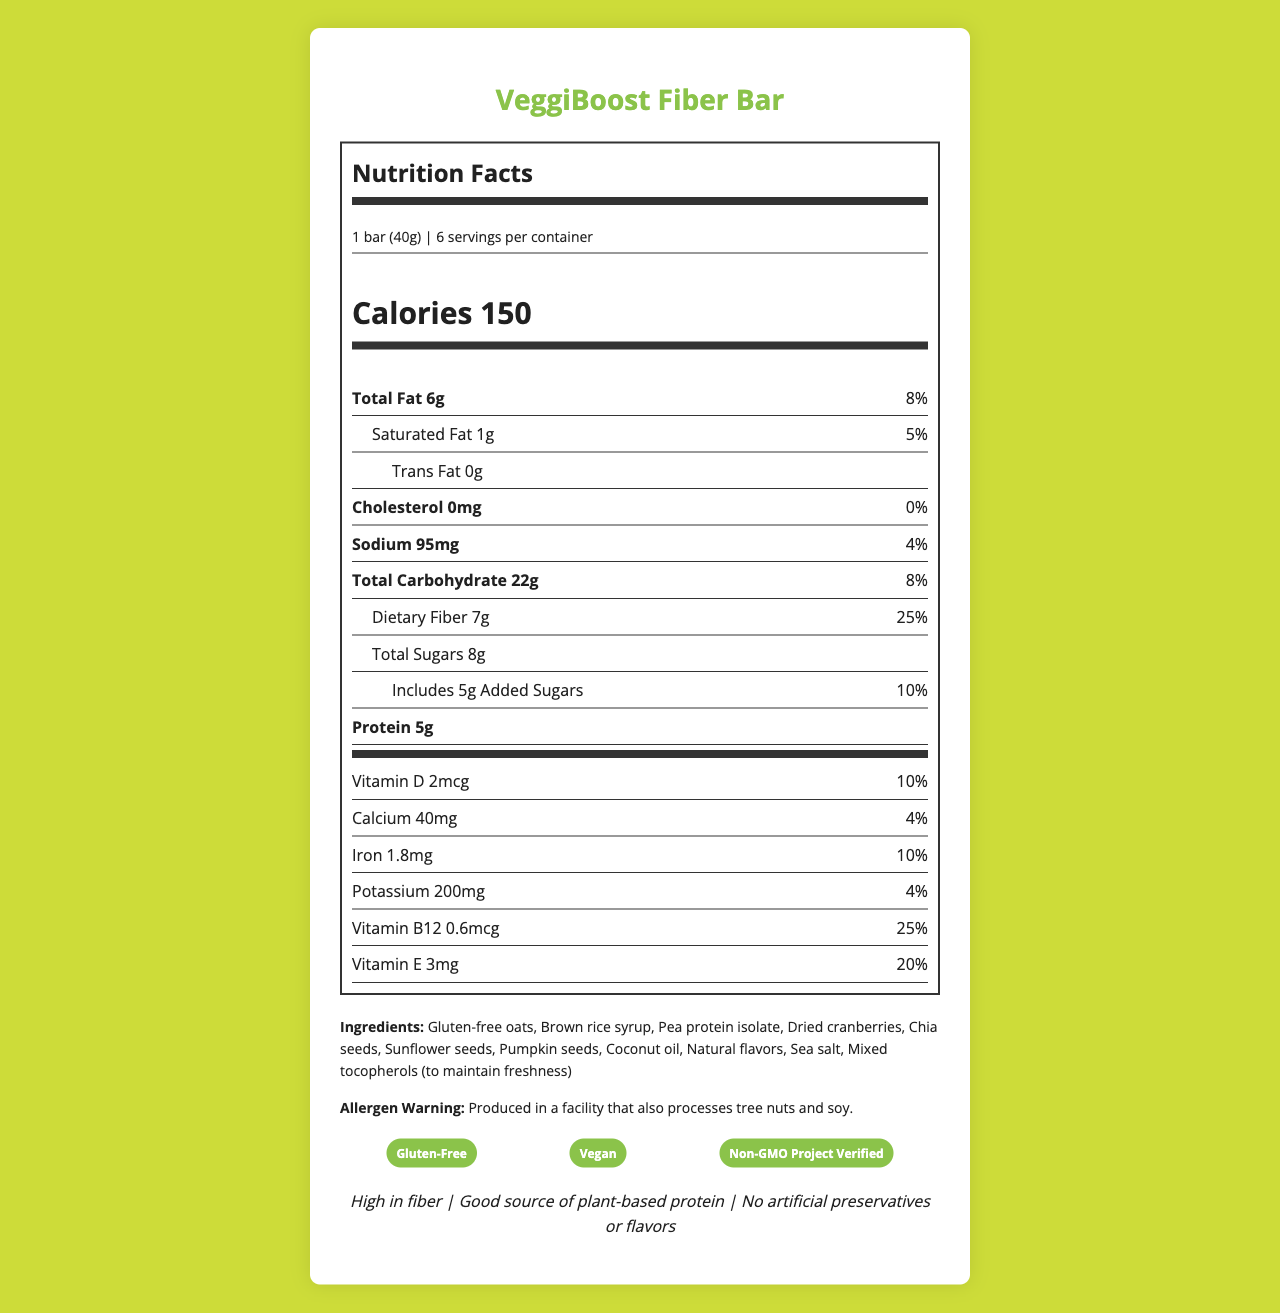What is the serving size specified for the VeggiBoost Fiber Bar? The document states that the serving size for the VeggiBoost Fiber Bar is 1 bar (40g).
Answer: 1 bar (40g) How many calories are there per serving of the VeggiBoost Fiber Bar? The Nutrition Facts label indicates that each serving (1 bar) contains 150 calories.
Answer: 150 What are the total grams of dietary fiber in one serving? The label shows that each serving has 7g of dietary fiber.
Answer: 7g What is the percent daily value of Vitamin B12 in one serving? The document specifies that one serving contains 25% of the daily value of Vitamin B12.
Answer: 25% Which ingredient is listed first in the ingredients section? The ingredients are listed in order of quantity, and gluten-free oats are mentioned first.
Answer: Gluten-free oats Is the VeggiBoost Fiber Bar produced in a facility that processes tree nuts? The allergen warning states that the product is produced in a facility that also processes tree nuts and soy.
Answer: Yes How many servings are there per container of VeggiBoost Fiber Bar? According to the document, there are 6 servings per container.
Answer: 6 How much sodium is in one serving of the VeggiBoost Fiber Bar? The label lists sodium content per serving as 95mg.
Answer: 95mg What allergens are mentioned in the allergen warning? A. Dairy B. Tree Nuts C. Soy D. Eggs The allergen warning indicates that the product is produced in a facility that also processes tree nuts and soy.
Answer: B and C What is the primary marketing claim of the VeggiBoost Fiber Bar? A. Low in sodium B. High in fiber C. Contains dairy D. Contains artificial flavors The marketing claims section clearly states "High in fiber" as one of the primary marketing claims.
Answer: B Does the VeggiBoost Fiber Bar contain any artificial preservatives or flavors? The marketing claims specify that there are no artificial preservatives or flavors in the bar.
Answer: No Summarize the main idea of the document. The document is centered around the nutritional details, ingredients, allergens, certifications, and marketing claims for the VeggiBoost Fiber Bar, while also providing guidelines for web design and content management to display this information effectively online.
Answer: The document provides a detailed Nutrition Facts label for the VeggiBoost Fiber Bar, a gluten-free, vegan snack bar. It emphasizes the bar's high fiber content, a good plant-based protein source, and lack of artificial preservatives or flavors. It also lists ingredients, allergens, certifications, and marketing claims along with web design considerations and CMS tips. What is the percentage of the daily value for Iron in the VeggiBoost Fiber Bar? The Nutrition Facts label indicates that the bar contains 10% of the daily value of Iron per serving.
Answer: 10% What is the main source of protein in the VeggiBoost Fiber Bar? The ingredients list shows that pea protein isolate is the main source of protein in the bar.
Answer: Pea protein isolate Based on the label, does the VeggiBoost Fiber Bar claim to be Non-GMO? The certifications section includes "Non-GMO Project Verified," indicating the product is Non-GMO.
Answer: Yes Who designed the web page for the nutrition label of VeggiBoost Fiber Bar? The document does not provide information about the designer of the web page.
Answer: Cannot be determined 